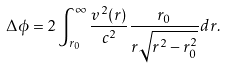<formula> <loc_0><loc_0><loc_500><loc_500>\Delta \phi = 2 \int _ { r _ { 0 } } ^ { \infty } \frac { v ^ { 2 } ( r ) } { c ^ { 2 } } \frac { r _ { 0 } } { r \sqrt { r ^ { 2 } - r _ { 0 } ^ { 2 } } } d r .</formula> 